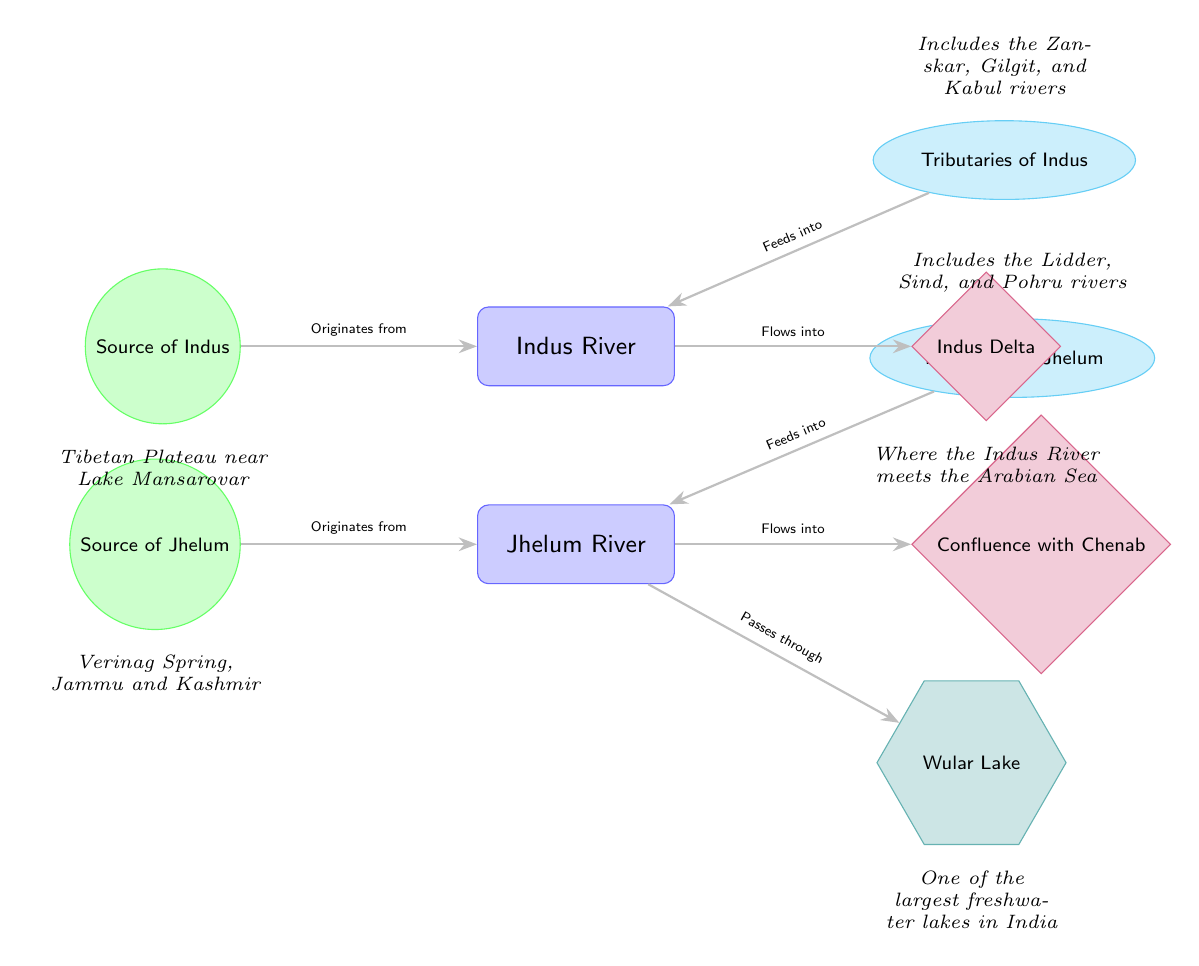What's the source of the Indus River? The diagram indicates that the Indus River originates from the Tibetan Plateau near Lake Mansarovar, which is specified in the description attached to the source node connected to the Indus River.
Answer: Tibetan Plateau near Lake Mansarovar What are the tributaries of the Jhelum River? The diagram shows that the tributaries feeding into the Jhelum River include the Lidder, Sind, and Pohru rivers, as noted in the description associated with the tributary node for Jhelum.
Answer: Lidder, Sind, and Pohru Where does the Jhelum River flow into? According to the diagram, the Jhelum River flows into the Chenab River, as indicated by the arrow and label connecting Jhelum to the confluence node labeled as the Confluence with Chenab.
Answer: Confluence with Chenab What is the significance of Wular Lake? Wular Lake is noted in the diagram as one of the largest freshwater lakes in India, and it is connected to the Jhelum River, which indicates its importance in the river system as a lake that the river passes through.
Answer: One of the largest freshwater lakes in India How many sources are depicted in the diagram? The diagram includes two sources, one for the Indus River and one for the Jhelum River. Counting the source nodes present for each river confirms this.
Answer: 2 What flows into the Indus Delta? The diagram shows that the Indus River flows into the Indus Delta, as indicated by the arrow labeled "Flows into" connecting Indus River to the Indus Delta node.
Answer: Indus River Which rivers are tributaries of the Indus River? The description for the tributary node of Indus indicates that the Zanskar, Gilgit, and Kabul rivers are tributaries, and these are identified in the diagram's connected description.
Answer: Zanskar, Gilgit, and Kabul What shape is used to represent the sources of the rivers? The diagram uses circles to represent the sources of the rivers, distinguishing these source nodes from other types of nodes in the diagram with different shapes.
Answer: Circle 